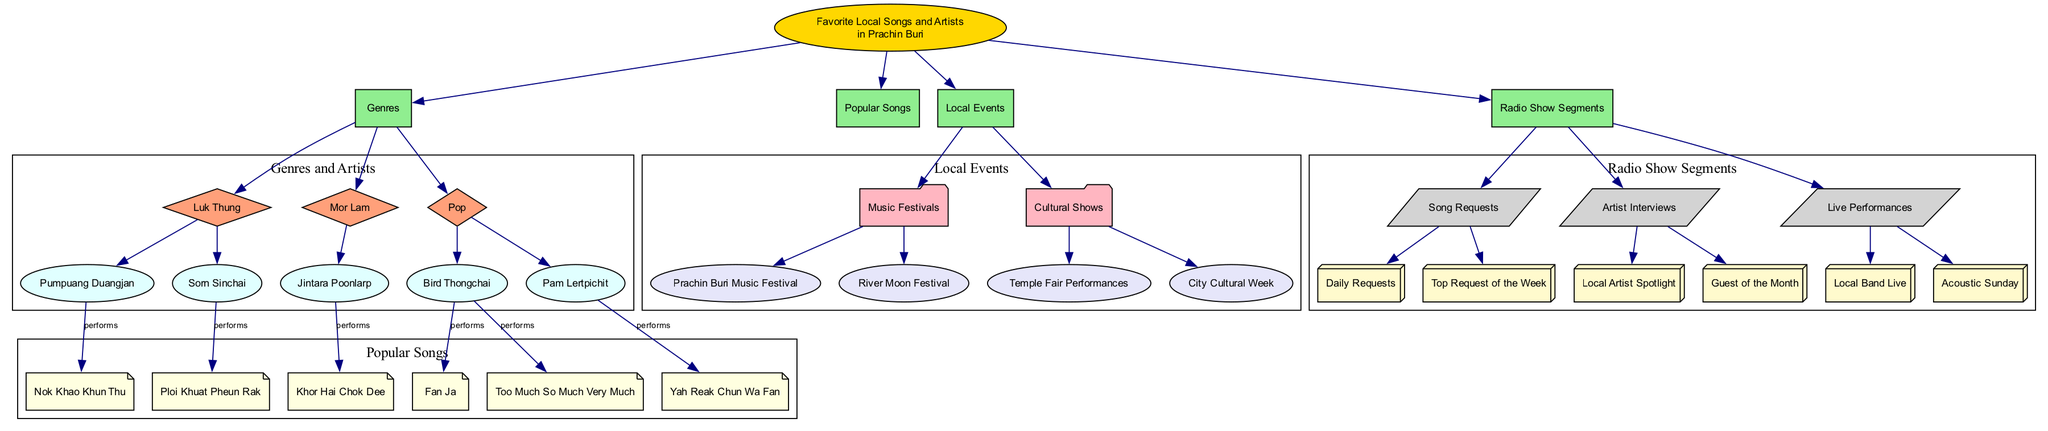What are the two genres listed in the diagram? The diagram shows 'Luk Thung' and 'Mor Lam' as two of the genres listed under 'Genres'. There are multiple genres, but only these two are being specifically asked.
Answer: Luk Thung, Mor Lam How many artists are associated with 'Luk Thung'? In the diagram, 'Luk Thung' has two associated artists listed: 'Pumpuang Duangjan' and 'Sorn Sinchai'. Therefore, the count is based directly on what is shown under 'Luk Thung'.
Answer: 2 Which local event is related to music? The diagram mentions 'Prachin Buri Music Festival' and 'River Moon Festival' as events under 'Music Festivals', which are local music-related events.
Answer: Prachin Buri Music Festival Which artist performs the song 'Fan Ja'? In the 'Popular Songs' section, the song 'Fan Ja' is connected to the artist 'Bird Thongchai', indicating that he performs this song.
Answer: Bird Thongchai What type of segment is 'Local Artist Spotlight'? The 'Artist Interviews' node under 'Radio Show Segments' includes 'Local Artist Spotlight', meaning this segment falls under that category, clearly defining its type.
Answer: Artist Interviews How many 'Local Events' are listed in the diagram? The diagram contains a total of four local events: 'Prachin Buri Music Festival', 'River Moon Festival', 'Temple Fair Performances', and 'City Cultural Week'. By counting these events under 'Local Events', we determine the total.
Answer: 4 What is the relationship between 'Bird Thongchai' and 'Too Much So Much Very Much'? The diagram shows that 'Too Much So Much Very Much' is performed by 'Bird Thongchai', indicating a direct connection where the artist is responsible for that song.
Answer: performs Which genre includes 'Jintara Poonlarp'? The diagram indicates that 'Jintara Poonlarp' is associated with the 'Mor Lam' genre, connecting the artist directly with this specific genre category.
Answer: Mor Lam What does the event 'City Cultural Week' entail? This event falls under 'Local Events', but the diagram does not provide further details, indicating it as a general cultural event without specific descriptions.
Answer: Cultural event 